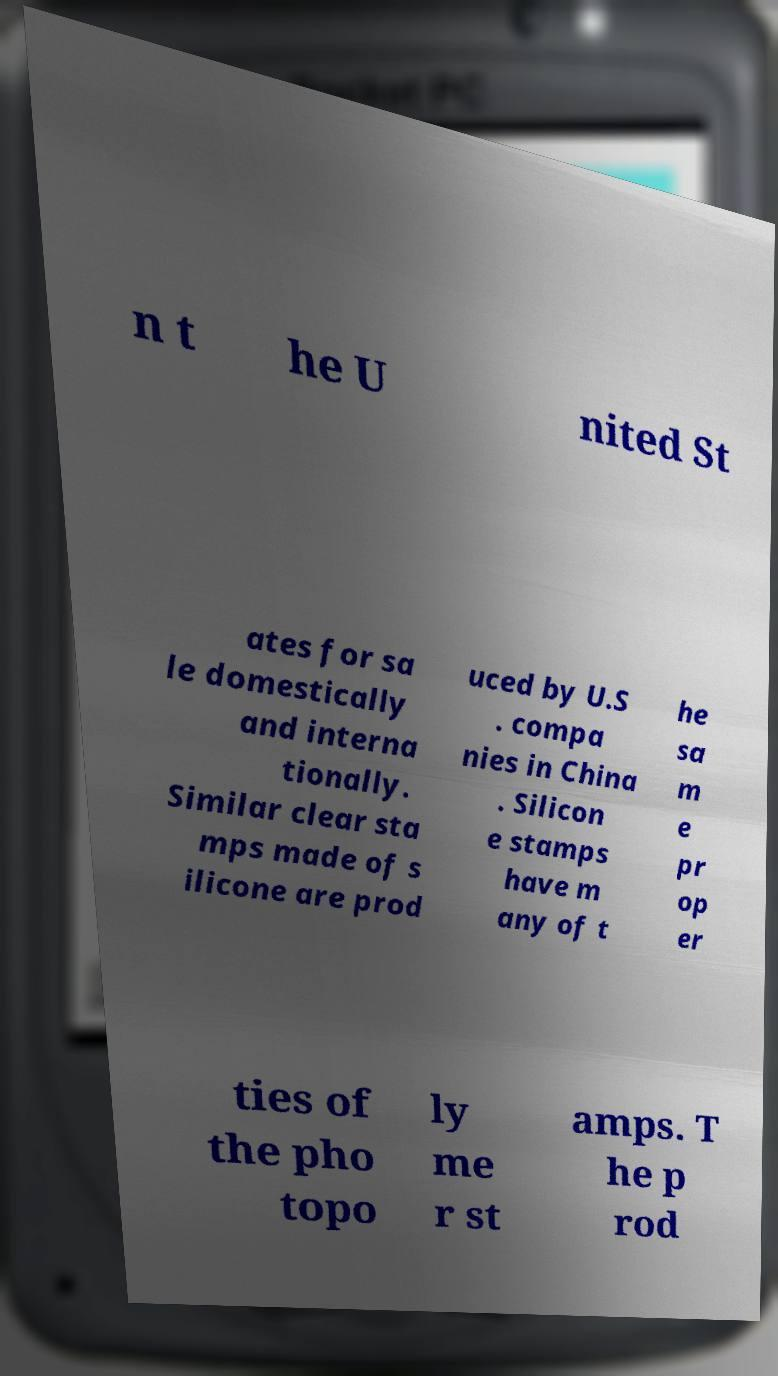For documentation purposes, I need the text within this image transcribed. Could you provide that? n t he U nited St ates for sa le domestically and interna tionally. Similar clear sta mps made of s ilicone are prod uced by U.S . compa nies in China . Silicon e stamps have m any of t he sa m e pr op er ties of the pho topo ly me r st amps. T he p rod 